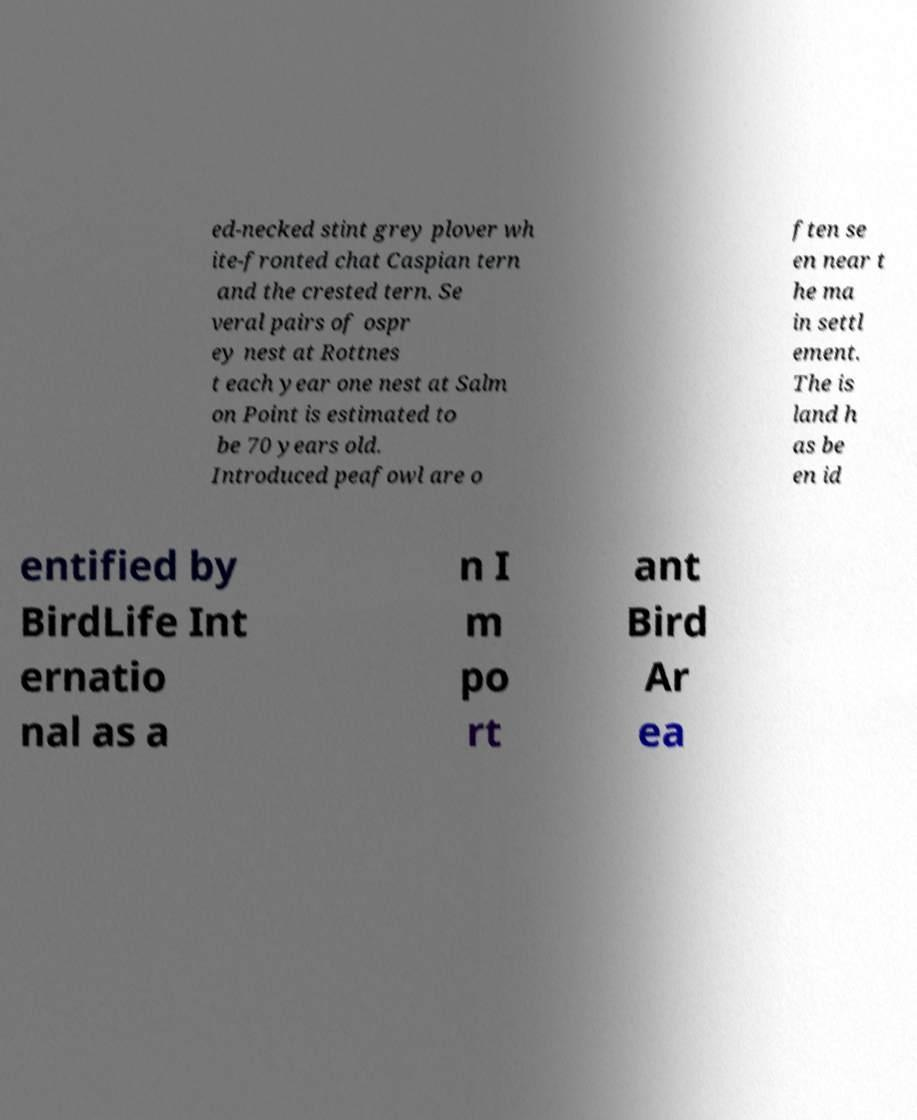Please read and relay the text visible in this image. What does it say? ed-necked stint grey plover wh ite-fronted chat Caspian tern and the crested tern. Se veral pairs of ospr ey nest at Rottnes t each year one nest at Salm on Point is estimated to be 70 years old. Introduced peafowl are o ften se en near t he ma in settl ement. The is land h as be en id entified by BirdLife Int ernatio nal as a n I m po rt ant Bird Ar ea 